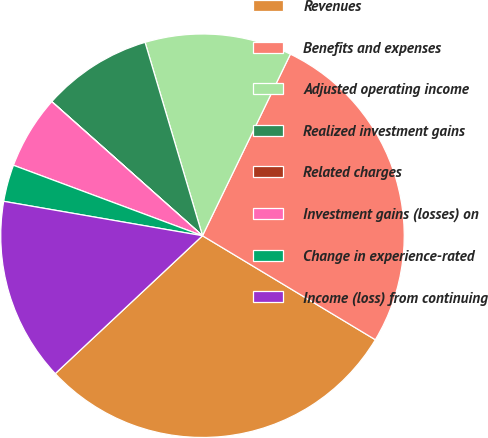Convert chart. <chart><loc_0><loc_0><loc_500><loc_500><pie_chart><fcel>Revenues<fcel>Benefits and expenses<fcel>Adjusted operating income<fcel>Realized investment gains<fcel>Related charges<fcel>Investment gains (losses) on<fcel>Change in experience-rated<fcel>Income (loss) from continuing<nl><fcel>29.4%<fcel>26.45%<fcel>11.77%<fcel>8.83%<fcel>0.01%<fcel>5.89%<fcel>2.95%<fcel>14.71%<nl></chart> 